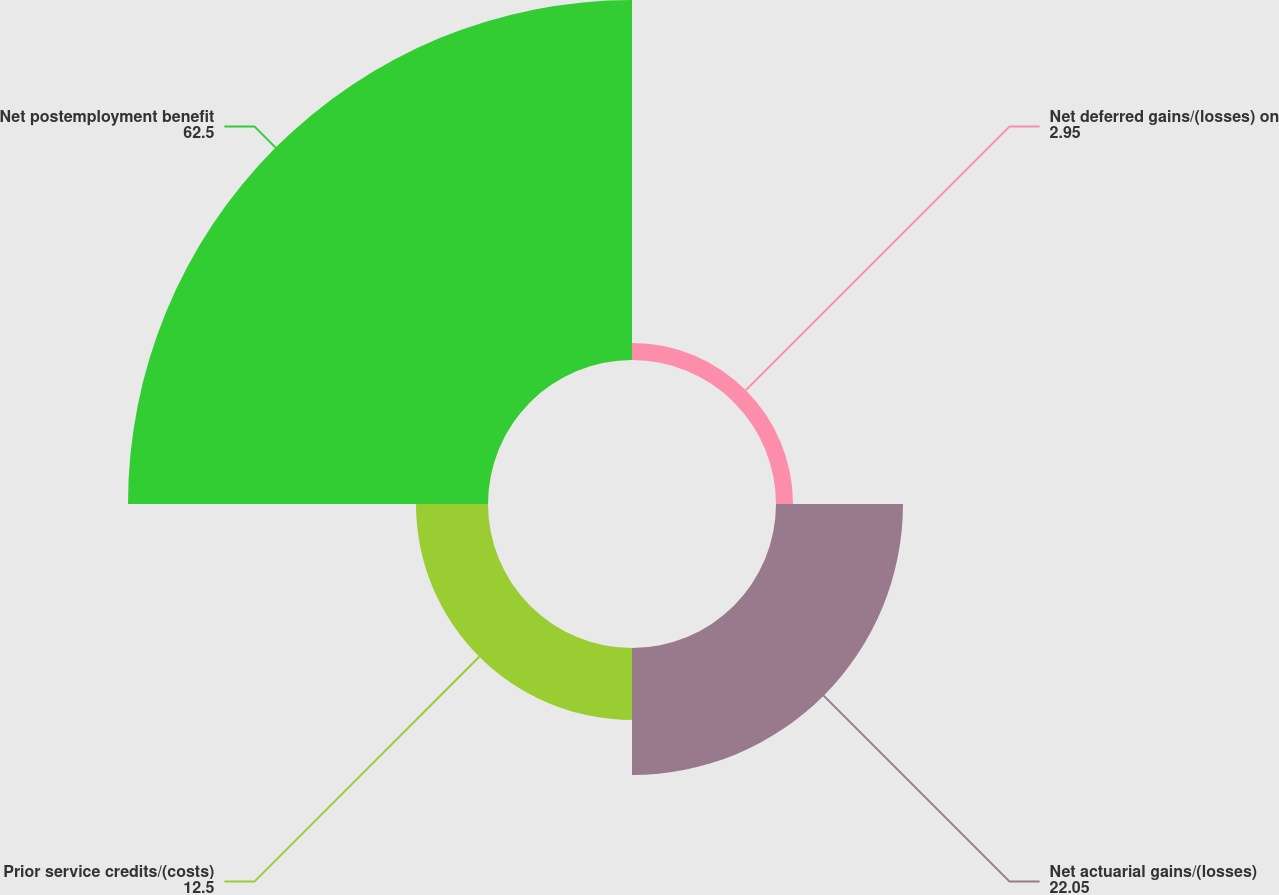<chart> <loc_0><loc_0><loc_500><loc_500><pie_chart><fcel>Net deferred gains/(losses) on<fcel>Net actuarial gains/(losses)<fcel>Prior service credits/(costs)<fcel>Net postemployment benefit<nl><fcel>2.95%<fcel>22.05%<fcel>12.5%<fcel>62.5%<nl></chart> 